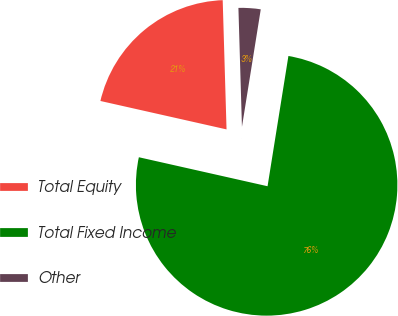Convert chart to OTSL. <chart><loc_0><loc_0><loc_500><loc_500><pie_chart><fcel>Total Equity<fcel>Total Fixed Income<fcel>Other<nl><fcel>21.0%<fcel>76.0%<fcel>3.0%<nl></chart> 